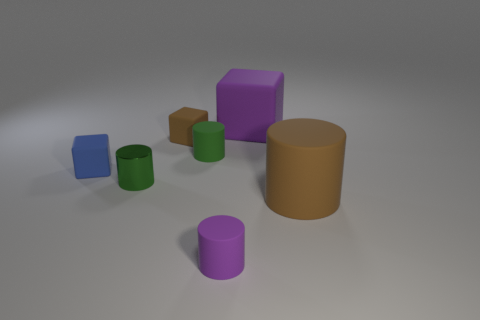What size is the object that is the same color as the big matte cylinder?
Offer a terse response. Small. There is a big brown object; is its shape the same as the large thing behind the tiny green metallic cylinder?
Make the answer very short. No. What is the size of the purple rubber object that is the same shape as the large brown matte thing?
Make the answer very short. Small. Is the color of the big rubber cylinder the same as the cube that is on the left side of the small green metallic object?
Your answer should be compact. No. How many other objects are there of the same size as the blue cube?
Ensure brevity in your answer.  4. What is the shape of the brown thing behind the matte cylinder that is right of the purple rubber object that is in front of the small green metallic cylinder?
Your response must be concise. Cube. There is a brown cylinder; does it have the same size as the purple object on the left side of the big purple block?
Your response must be concise. No. What color is the cube that is both to the right of the small green metallic thing and in front of the large purple thing?
Your answer should be compact. Brown. What number of other objects are there of the same shape as the large brown rubber object?
Provide a succinct answer. 3. Do the tiny object on the left side of the green metal cylinder and the big thing to the right of the large purple matte thing have the same color?
Provide a short and direct response. No. 